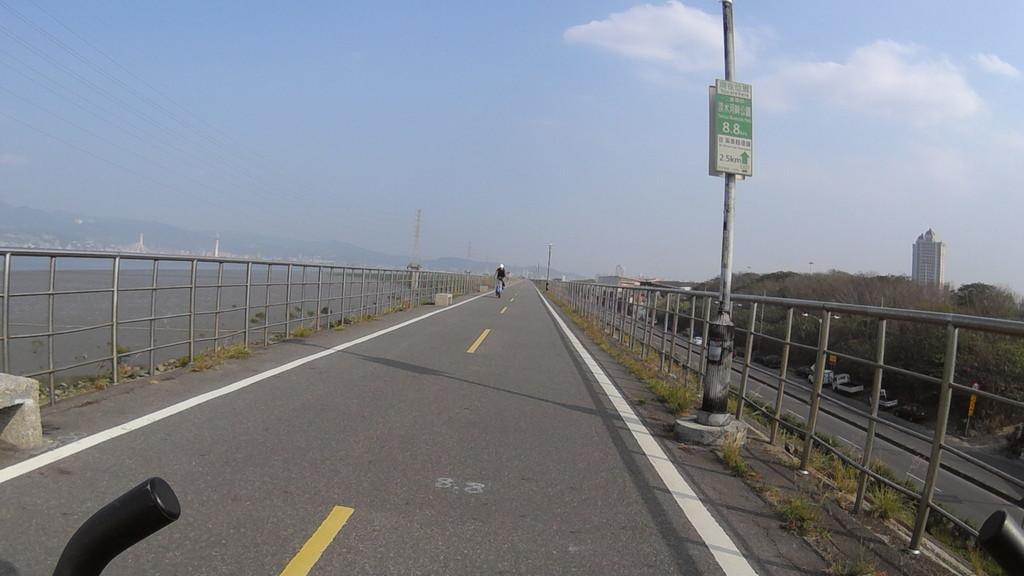How would you summarize this image in a sentence or two? This image is clicked on the road. Beside the road there are poles and a railing. There is a person riding a bicycle on the road. To the left there is water on the ground. To the right there are trees, a road, buildings and vehicles on the road. At the top there is the sky. In the background there are mountains. At the bottom there is a handle of a bicycle. 